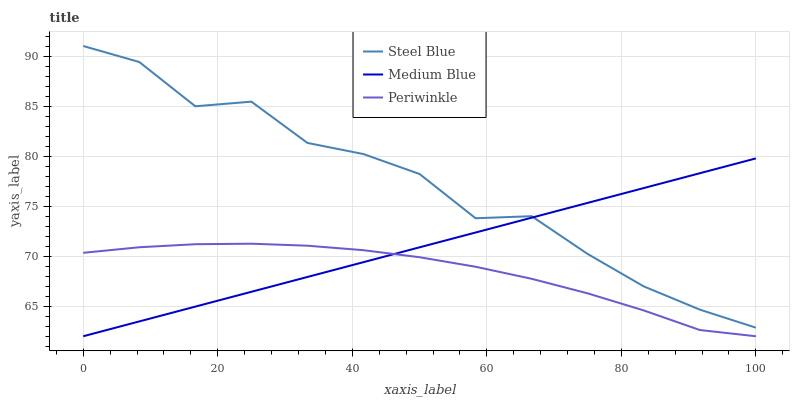Does Periwinkle have the minimum area under the curve?
Answer yes or no. Yes. Does Steel Blue have the maximum area under the curve?
Answer yes or no. Yes. Does Medium Blue have the minimum area under the curve?
Answer yes or no. No. Does Medium Blue have the maximum area under the curve?
Answer yes or no. No. Is Medium Blue the smoothest?
Answer yes or no. Yes. Is Steel Blue the roughest?
Answer yes or no. Yes. Is Steel Blue the smoothest?
Answer yes or no. No. Is Medium Blue the roughest?
Answer yes or no. No. Does Steel Blue have the lowest value?
Answer yes or no. No. Does Medium Blue have the highest value?
Answer yes or no. No. Is Periwinkle less than Steel Blue?
Answer yes or no. Yes. Is Steel Blue greater than Periwinkle?
Answer yes or no. Yes. Does Periwinkle intersect Steel Blue?
Answer yes or no. No. 